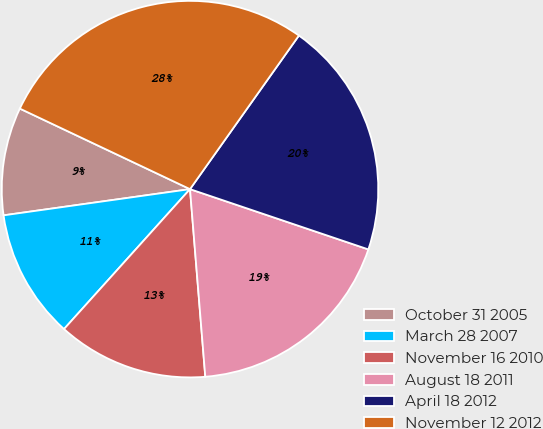Convert chart. <chart><loc_0><loc_0><loc_500><loc_500><pie_chart><fcel>October 31 2005<fcel>March 28 2007<fcel>November 16 2010<fcel>August 18 2011<fcel>April 18 2012<fcel>November 12 2012<nl><fcel>9.26%<fcel>11.11%<fcel>12.96%<fcel>18.52%<fcel>20.37%<fcel>27.78%<nl></chart> 